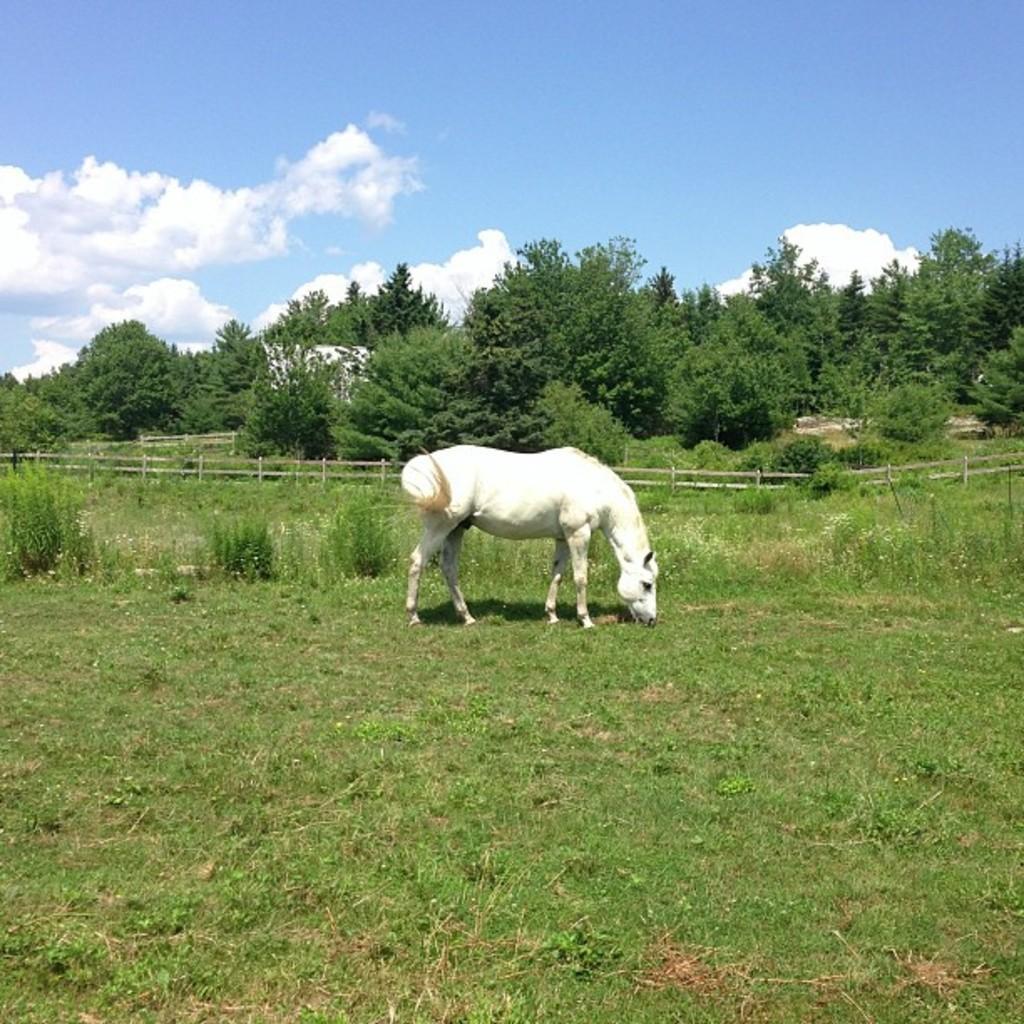Please provide a concise description of this image. The picture is taken in a field. In the foreground there are shrubs, horse and grass. In the center of the picture there are trees and fencing. At the top it is sky. 